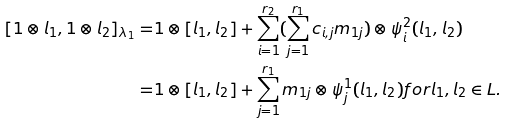<formula> <loc_0><loc_0><loc_500><loc_500>[ 1 \otimes l _ { 1 } , 1 \otimes l _ { 2 } ] _ { \lambda _ { 1 } } = & 1 \otimes [ l _ { 1 } , l _ { 2 } ] + \sum _ { i = 1 } ^ { r _ { 2 } } ( \sum _ { j = 1 } ^ { r _ { 1 } } c _ { i , j } m _ { 1 j } ) \otimes \psi ^ { 2 } _ { i } ( l _ { 1 } , l _ { 2 } ) \\ = & 1 \otimes [ l _ { 1 } , l _ { 2 } ] + \sum _ { j = 1 } ^ { r _ { 1 } } m _ { 1 j } \otimes \psi ^ { 1 } _ { j } ( l _ { 1 } , l _ { 2 } ) f o r l _ { 1 } , l _ { 2 } \in L .</formula> 